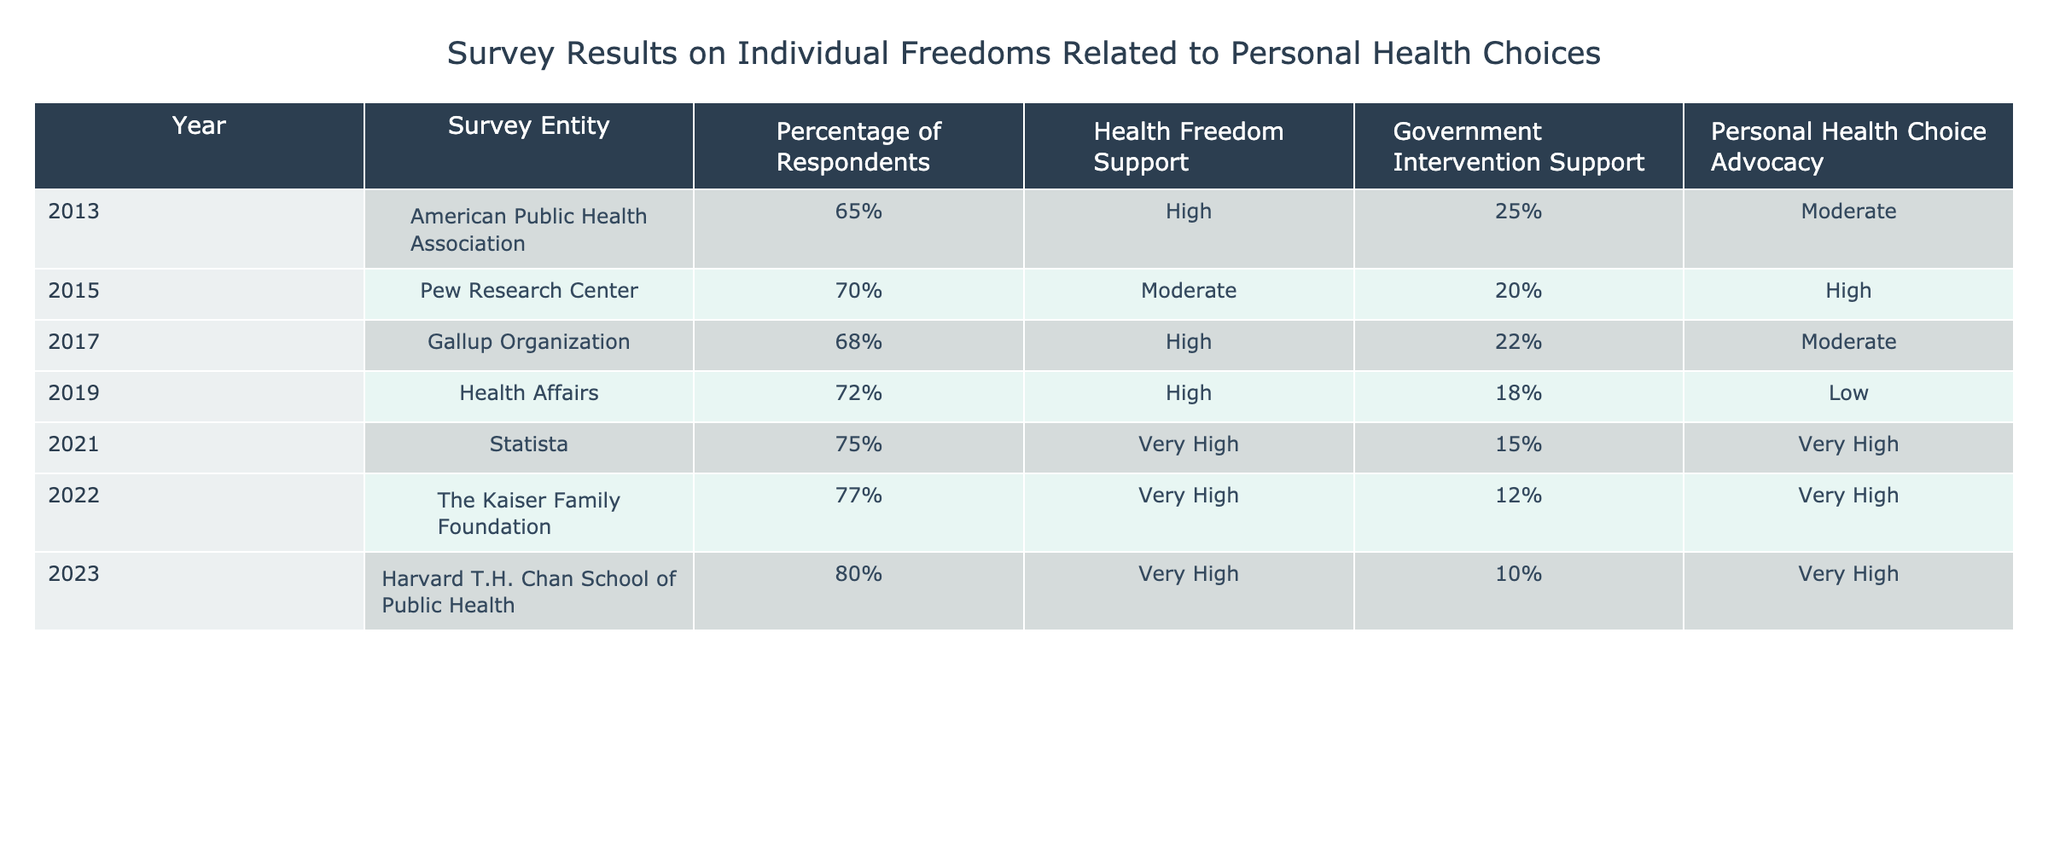What was the percentage of respondents who supported health freedom in 2023? In 2023, the survey results show that the percentage of respondents who supported health freedom is listed as 80%.
Answer: 80% Which survey entity reported the lowest government intervention support? By comparing the values in the government intervention support column, The Kaiser Family Foundation in 2022 reported the lowest support at 12%.
Answer: 12% What is the trend in personal health choice advocacy from 2013 to 2023? By reviewing the personal health choice advocacy column, we observe that it starts at Moderate in 2013, moves to Low in 2019, and then reaches Very High by 2023. Thus, there is a clear upward trend in advocacy over the years.
Answer: Upward trend Did any survey from 2013 to 2023 report a percentage lower than 60% regarding health freedom support? Reviewing the data, all percentages in the health freedom support column are above 60%, indicating that no survey reported lower than that percentage.
Answer: No What was the average percentage of respondents supporting government intervention from 2013-2023? To find the average, we sum the government intervention support percentages: 25 + 20 + 22 + 18 + 15 + 12 + 10 = 132. There are 7 data points, so the average is 132/7 = approximately 18.86%.
Answer: Approximately 18.86% Which year showed the highest percentage of personal health choice advocacy? The year 2023 reported the highest percentage of personal health choice advocacy with the designation of Very High.
Answer: 2023 In which year did the percentage of respondents in favor of health freedom first exceed 70%? Looking at the health freedom support column, the percentage first exceeds 70% in 2015, which shows a value of 70%.
Answer: 2015 Is there a year where health freedom support increased while government intervention support decreased? In the data from 2019 to 2021, health freedom support increased from 72% to 75%, and government intervention support decreased from 18% to 15%. Thus, this condition is met between those years.
Answer: Yes 